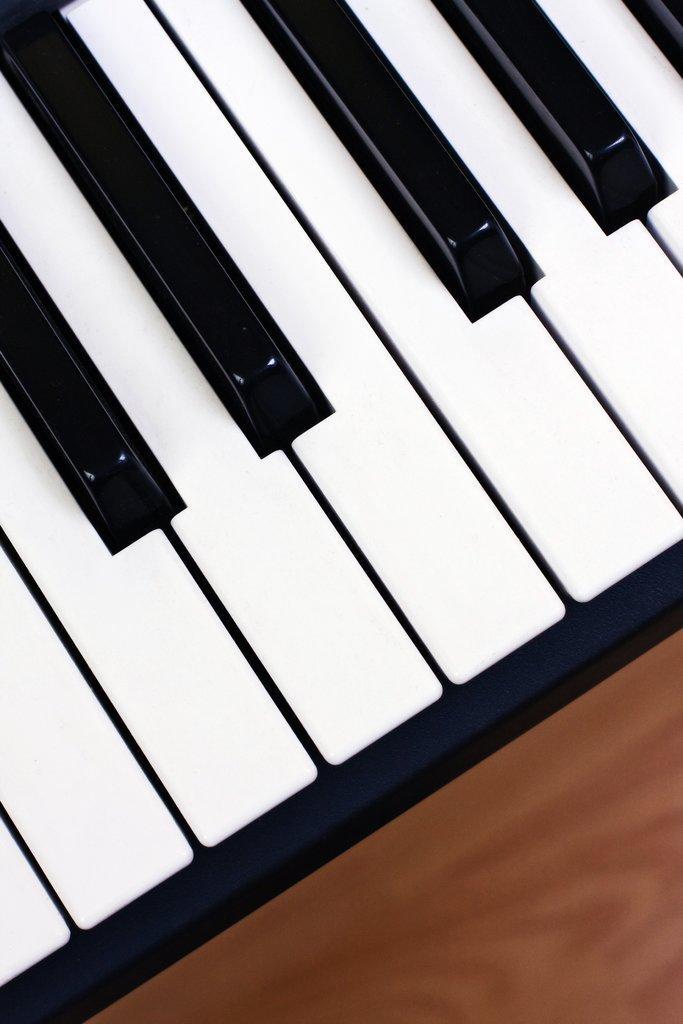How would you summarize this image in a sentence or two? We can see piano keyboard. 